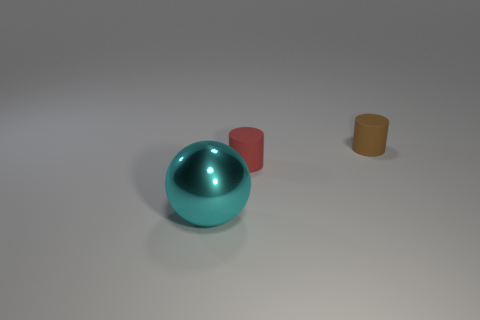What number of small things are either spheres or brown rubber cylinders? The image displays a total of three small objects: one teal sphere and two cylinders, one red and one brown. The sphere, with its reflective surface and round shape, is distinctly different from the two cylinders. Among the cylinders, one matches the description provided as a brown rubber cylinder. Therefore, the count of small things that are either spheres or brown rubber cylinders is two. 